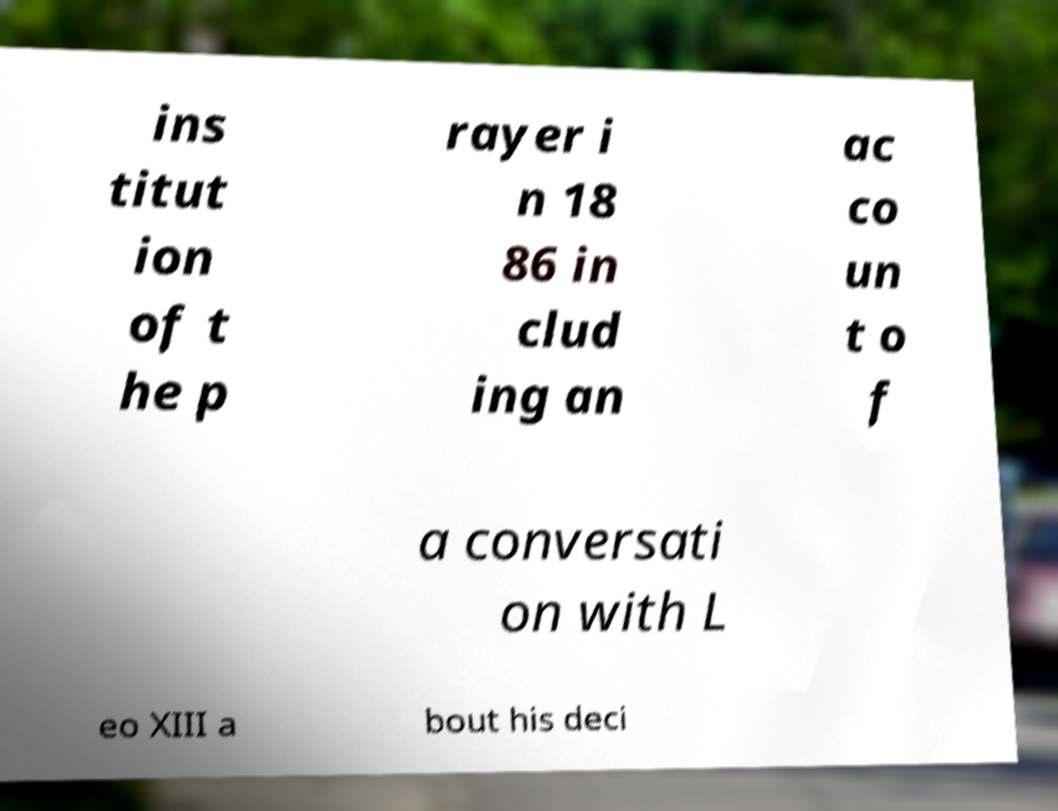For documentation purposes, I need the text within this image transcribed. Could you provide that? ins titut ion of t he p rayer i n 18 86 in clud ing an ac co un t o f a conversati on with L eo XIII a bout his deci 